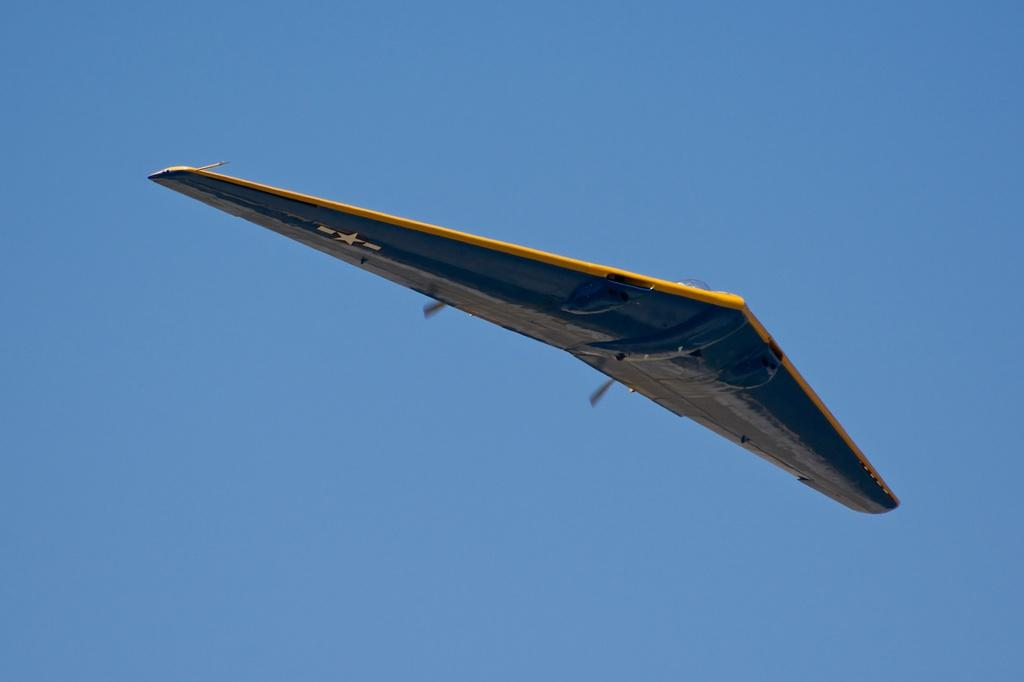What is the main subject of the image? The main subject of the image is a flying jet. Where is the jet located in the image? The jet is in the air in the image. What color is the sky in the image? The sky is blue in the image. How many dolls are sitting on the donkey in the image? There are no dolls or donkeys present in the image; it features a flying jet in the sky. 